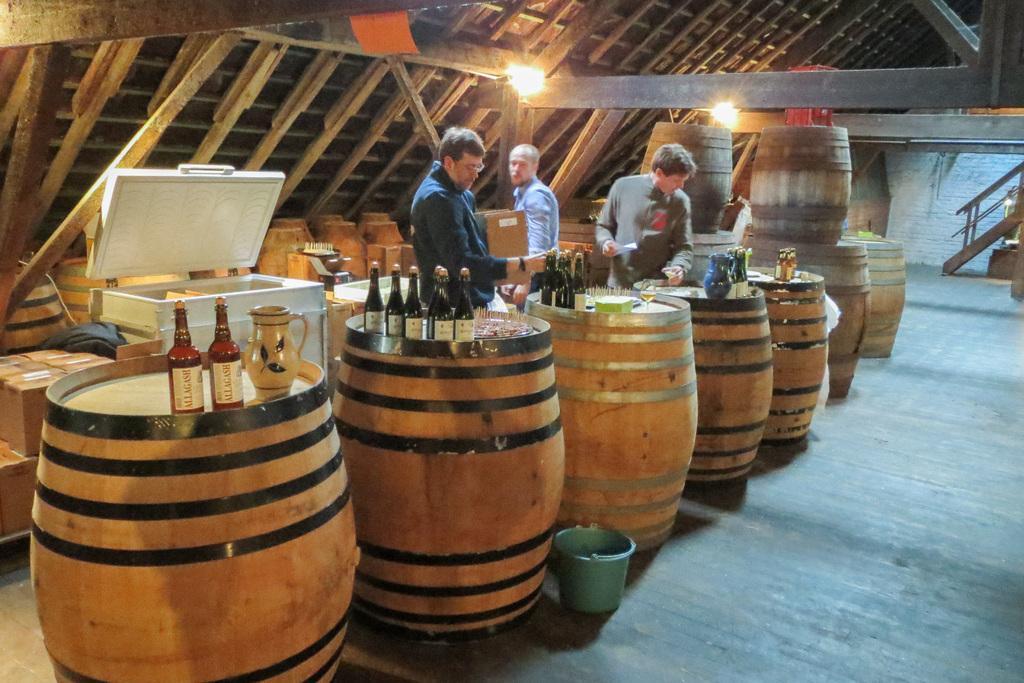In one or two sentences, can you explain what this image depicts? In this picture, we see three men are standing. In front of them, we see the tables which look like drums. On the tables, we see glass bottles and a jug. Beside that, we see a green color bucket. Behind them, we see many carton boxes and a white color box. On the right side, we see the staircase. In the background, we see a wooden wall and the lights. 